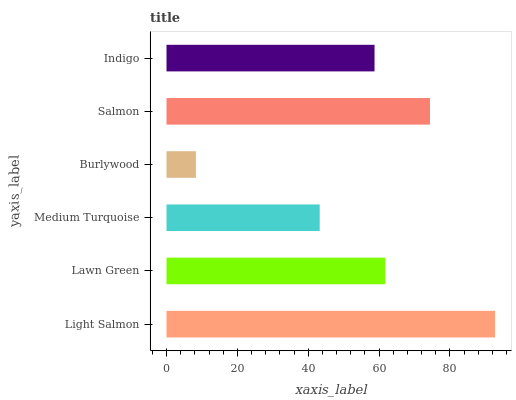Is Burlywood the minimum?
Answer yes or no. Yes. Is Light Salmon the maximum?
Answer yes or no. Yes. Is Lawn Green the minimum?
Answer yes or no. No. Is Lawn Green the maximum?
Answer yes or no. No. Is Light Salmon greater than Lawn Green?
Answer yes or no. Yes. Is Lawn Green less than Light Salmon?
Answer yes or no. Yes. Is Lawn Green greater than Light Salmon?
Answer yes or no. No. Is Light Salmon less than Lawn Green?
Answer yes or no. No. Is Lawn Green the high median?
Answer yes or no. Yes. Is Indigo the low median?
Answer yes or no. Yes. Is Salmon the high median?
Answer yes or no. No. Is Lawn Green the low median?
Answer yes or no. No. 